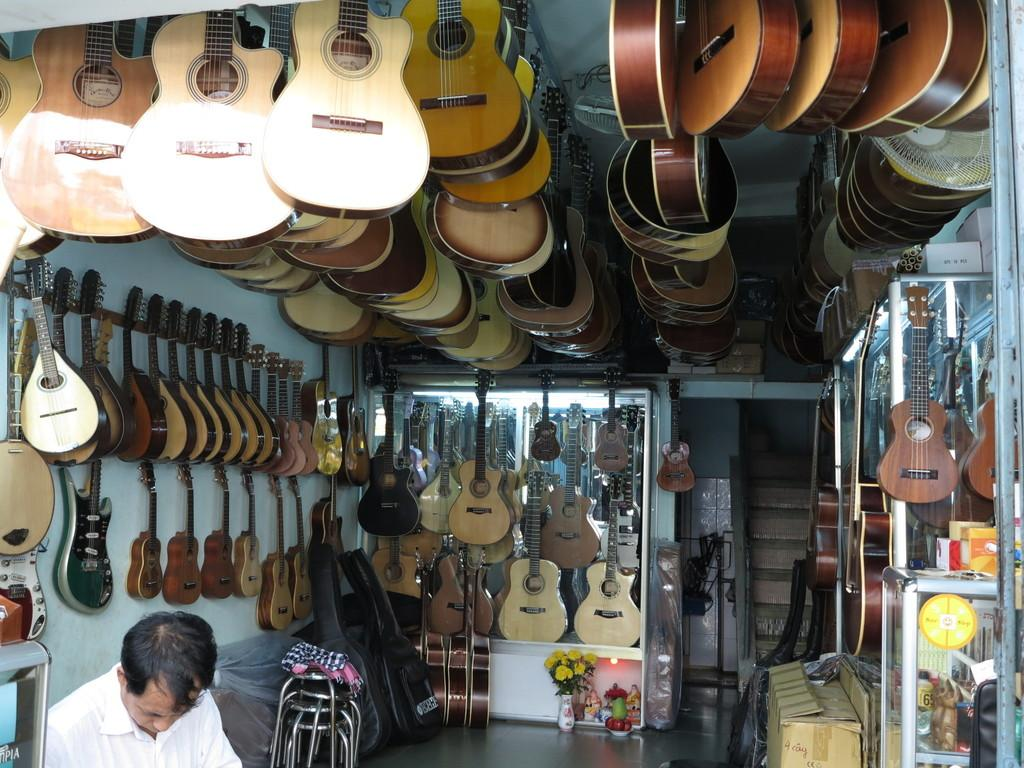What type of store is depicted in the image? The image is of a guitar shop. How are the guitars displayed in the shop? Many guitars can be seen on either side of the shop, as well as at the top. Can you describe the person in the image? There is a person in the left bottom corner of the image. Did the store experience an earthquake during the time the image was taken? There is no indication of an earthquake or any damage in the image. Can you tell me the direction of the zephyr blowing through the store? The image does not depict any zephyr or wind blowing through the store. 